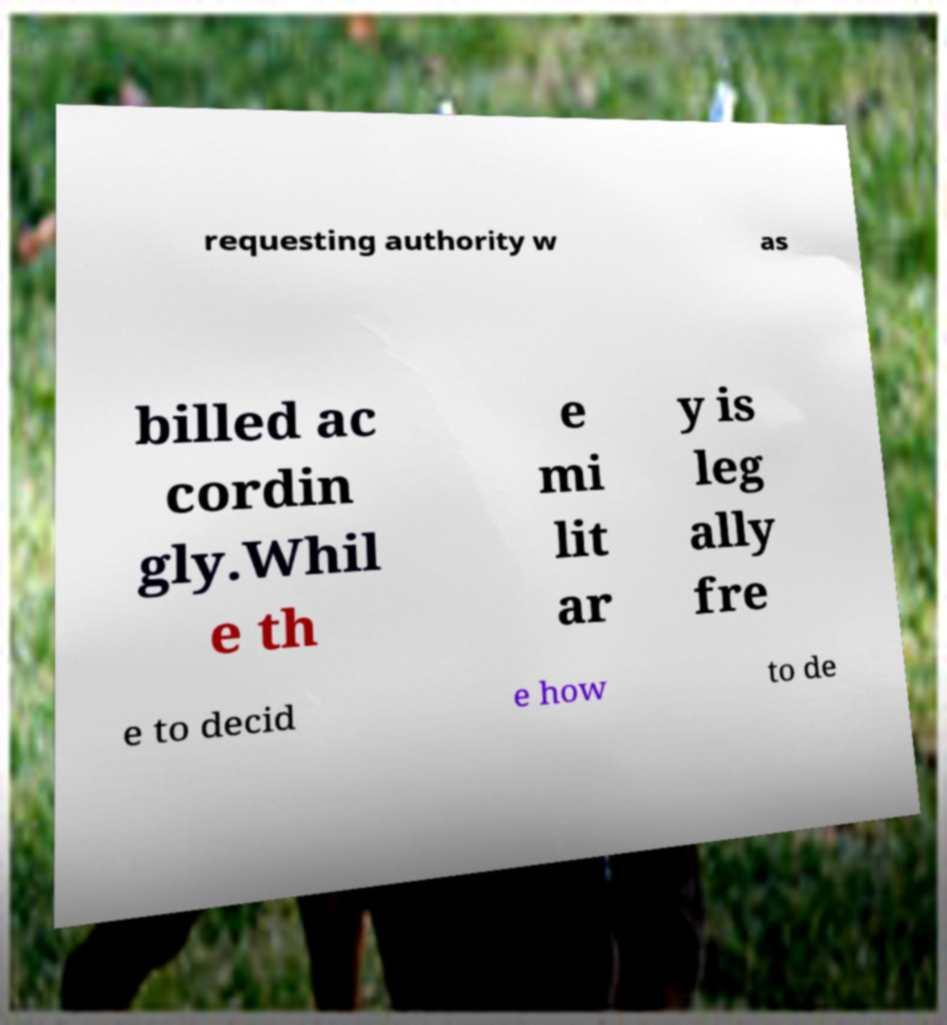Can you accurately transcribe the text from the provided image for me? requesting authority w as billed ac cordin gly.Whil e th e mi lit ar y is leg ally fre e to decid e how to de 